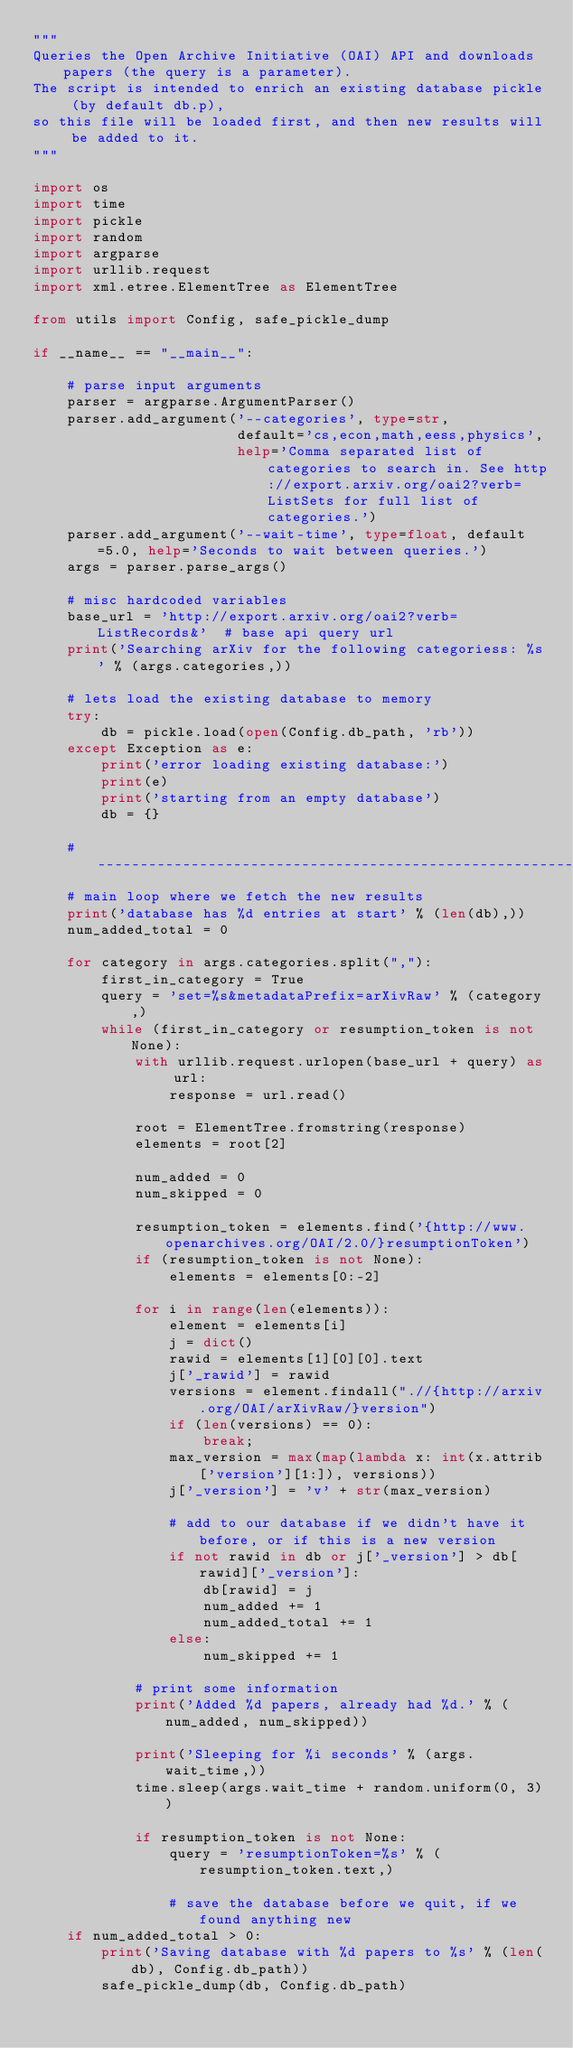<code> <loc_0><loc_0><loc_500><loc_500><_Python_>"""
Queries the Open Archive Initiative (OAI) API and downloads papers (the query is a parameter).
The script is intended to enrich an existing database pickle (by default db.p),
so this file will be loaded first, and then new results will be added to it.
"""

import os
import time
import pickle
import random
import argparse
import urllib.request
import xml.etree.ElementTree as ElementTree

from utils import Config, safe_pickle_dump

if __name__ == "__main__":

    # parse input arguments
    parser = argparse.ArgumentParser()
    parser.add_argument('--categories', type=str,
                        default='cs,econ,math,eess,physics',
                        help='Comma separated list of categories to search in. See http://export.arxiv.org/oai2?verb=ListSets for full list of categories.')
    parser.add_argument('--wait-time', type=float, default=5.0, help='Seconds to wait between queries.')
    args = parser.parse_args()

    # misc hardcoded variables
    base_url = 'http://export.arxiv.org/oai2?verb=ListRecords&'  # base api query url
    print('Searching arXiv for the following categoriess: %s' % (args.categories,))

    # lets load the existing database to memory
    try:
        db = pickle.load(open(Config.db_path, 'rb'))
    except Exception as e:
        print('error loading existing database:')
        print(e)
        print('starting from an empty database')
        db = {}

    # -----------------------------------------------------------------------------
    # main loop where we fetch the new results
    print('database has %d entries at start' % (len(db),))
    num_added_total = 0

    for category in args.categories.split(","):
        first_in_category = True
        query = 'set=%s&metadataPrefix=arXivRaw' % (category,)
        while (first_in_category or resumption_token is not None):
            with urllib.request.urlopen(base_url + query) as url:
                response = url.read()

            root = ElementTree.fromstring(response)
            elements = root[2]

            num_added = 0
            num_skipped = 0

            resumption_token = elements.find('{http://www.openarchives.org/OAI/2.0/}resumptionToken')
            if (resumption_token is not None):
                elements = elements[0:-2]

            for i in range(len(elements)):
                element = elements[i]
                j = dict()
                rawid = elements[1][0][0].text
                j['_rawid'] = rawid
                versions = element.findall(".//{http://arxiv.org/OAI/arXivRaw/}version")
                if (len(versions) == 0):
                    break;
                max_version = max(map(lambda x: int(x.attrib['version'][1:]), versions))
                j['_version'] = 'v' + str(max_version)

                # add to our database if we didn't have it before, or if this is a new version
                if not rawid in db or j['_version'] > db[rawid]['_version']:
                    db[rawid] = j
                    num_added += 1
                    num_added_total += 1
                else:
                    num_skipped += 1

            # print some information
            print('Added %d papers, already had %d.' % (num_added, num_skipped))

            print('Sleeping for %i seconds' % (args.wait_time,))
            time.sleep(args.wait_time + random.uniform(0, 3))

            if resumption_token is not None:
                query = 'resumptionToken=%s' % (resumption_token.text,)

                # save the database before we quit, if we found anything new
    if num_added_total > 0:
        print('Saving database with %d papers to %s' % (len(db), Config.db_path))
        safe_pickle_dump(db, Config.db_path)
</code> 